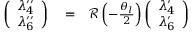<formula> <loc_0><loc_0><loc_500><loc_500>\begin{array} { r l r } { \left ( \begin{array} { c } { \lambda _ { 4 } ^ { \prime \prime } } \\ { \lambda _ { 6 } ^ { \prime \prime } } \end{array} \right ) } & = } & { { \mathcal { R } } \left ( - \frac { \theta _ { l } } { 2 } \right ) \left ( \begin{array} { c } { \lambda _ { 4 } ^ { \prime } } \\ { \lambda _ { 6 } ^ { \prime } } \end{array} \right ) } \end{array}</formula> 